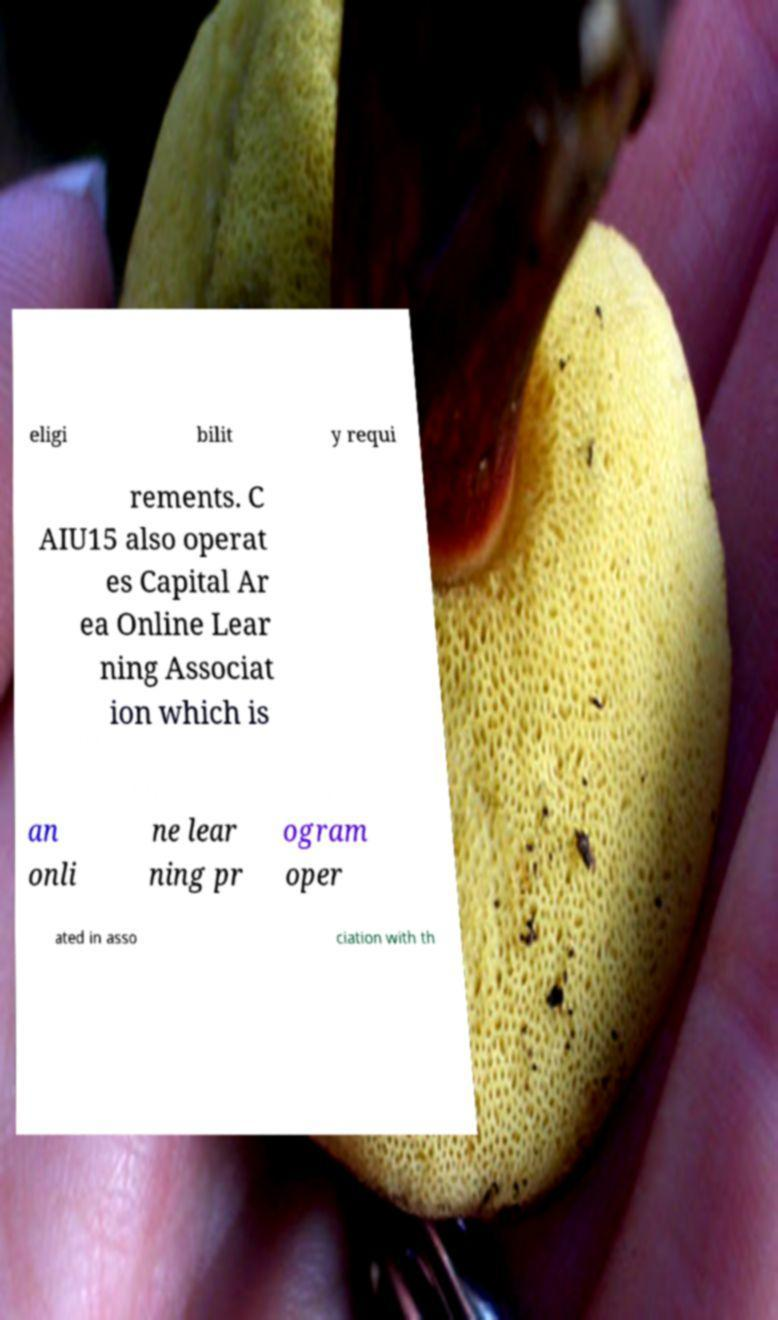What messages or text are displayed in this image? I need them in a readable, typed format. eligi bilit y requi rements. C AIU15 also operat es Capital Ar ea Online Lear ning Associat ion which is an onli ne lear ning pr ogram oper ated in asso ciation with th 